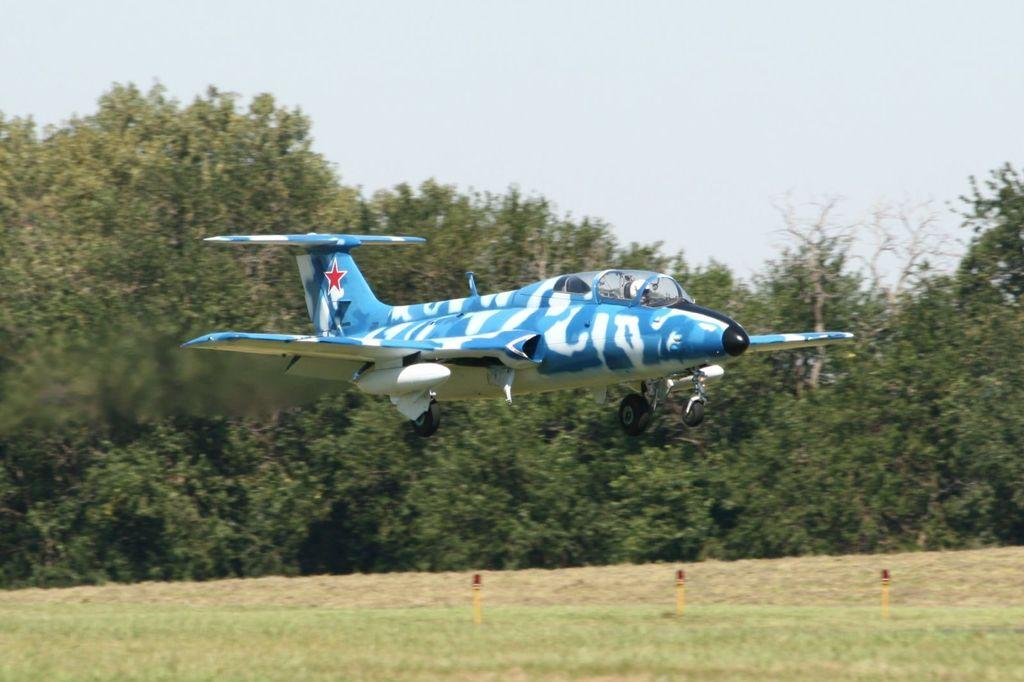What is the main subject of the image? The main subject of the image is an aircraft. What colors are used to paint the aircraft? The aircraft is in blue and white colors. Where is the aircraft located in the image? The aircraft is in the air. What can be seen in the background of the image? There are poles and trees visible in the background of the image. What is the color of the sky in the image? The sky is in white color. Can you see a key attached to the aircraft in the image? No, there is no key visible on the aircraft in the image. Is there any glue visible on the aircraft in the image? No, there is no glue visible on the aircraft in the image. 